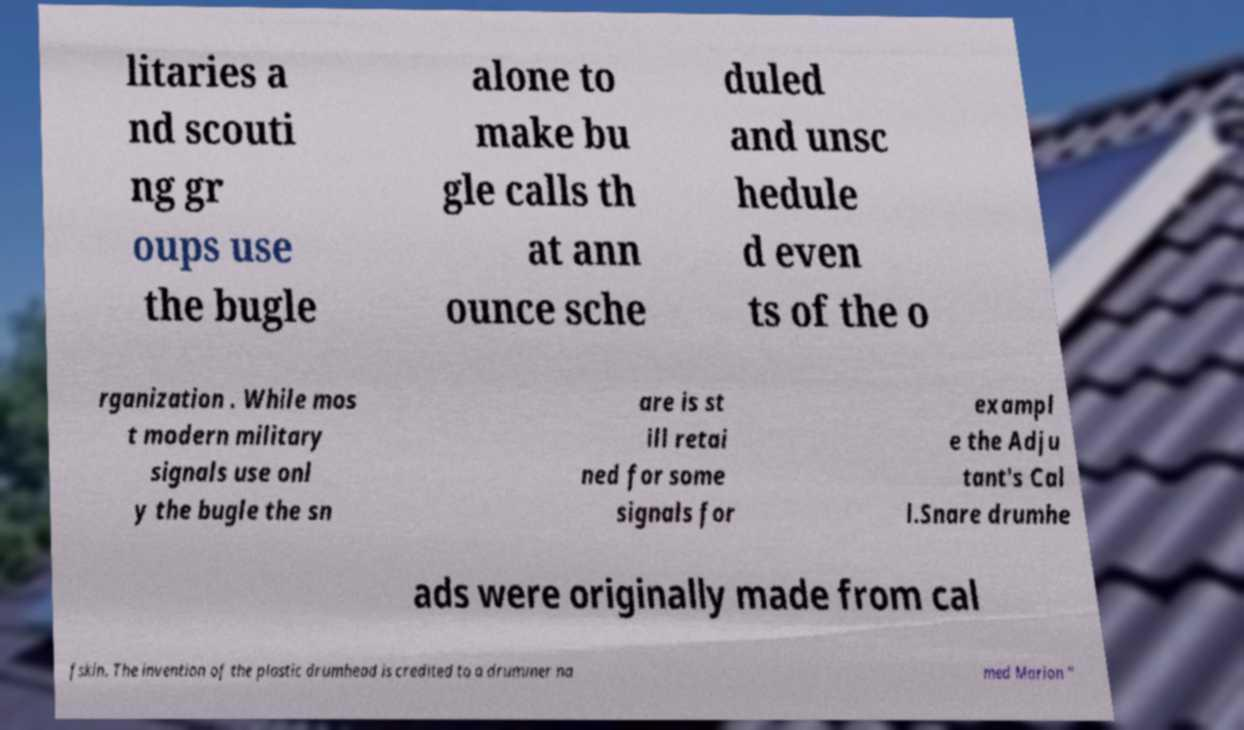What messages or text are displayed in this image? I need them in a readable, typed format. litaries a nd scouti ng gr oups use the bugle alone to make bu gle calls th at ann ounce sche duled and unsc hedule d even ts of the o rganization . While mos t modern military signals use onl y the bugle the sn are is st ill retai ned for some signals for exampl e the Adju tant's Cal l.Snare drumhe ads were originally made from cal fskin. The invention of the plastic drumhead is credited to a drummer na med Marion " 